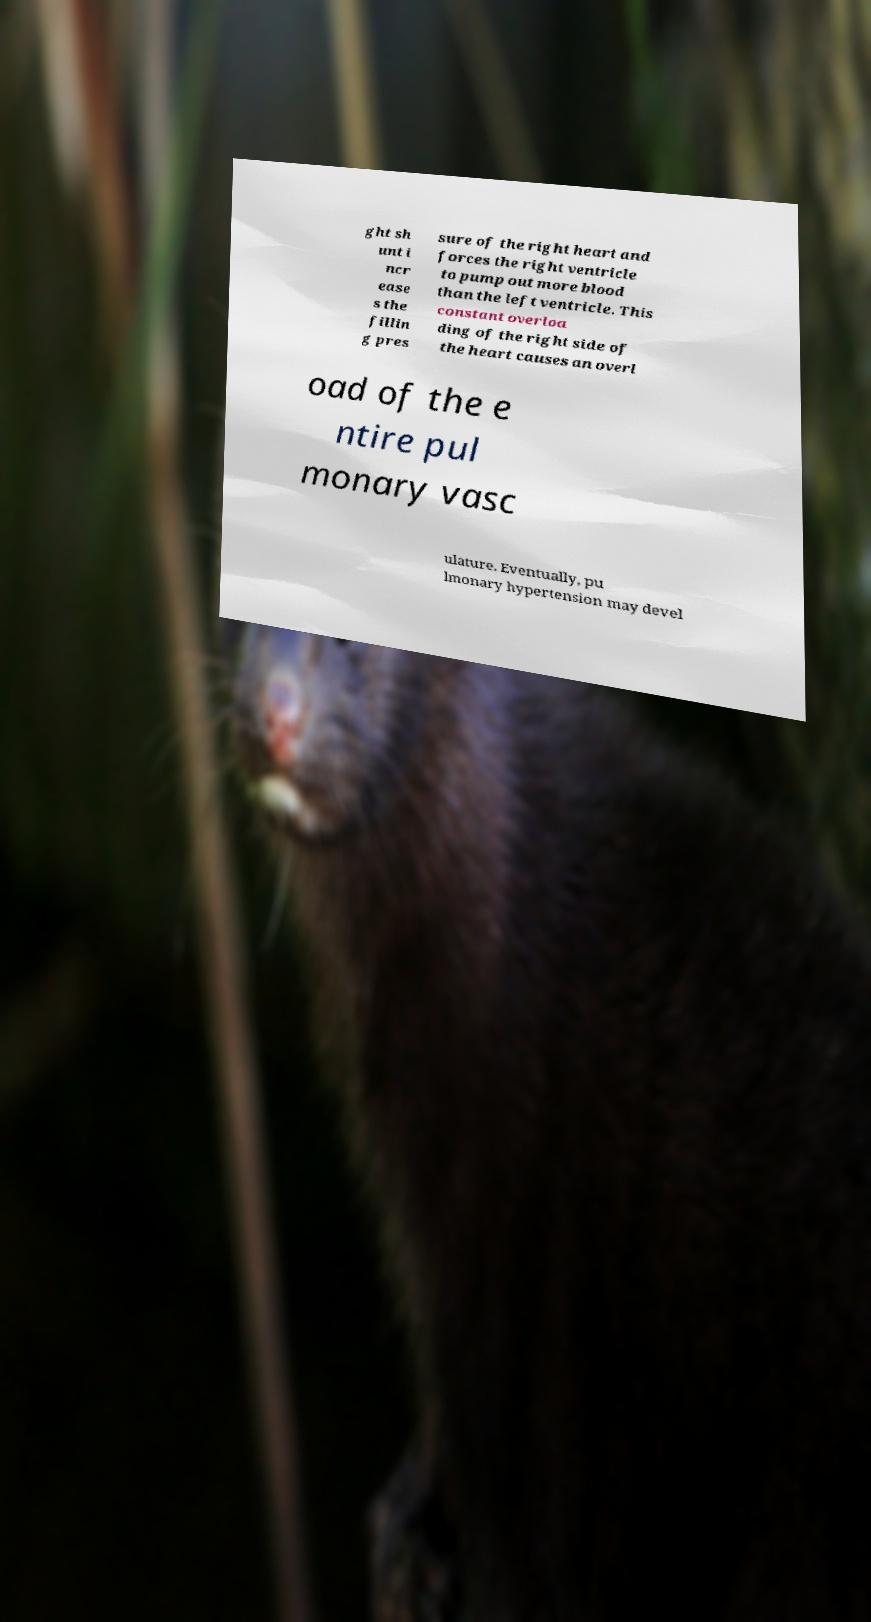Can you accurately transcribe the text from the provided image for me? ght sh unt i ncr ease s the fillin g pres sure of the right heart and forces the right ventricle to pump out more blood than the left ventricle. This constant overloa ding of the right side of the heart causes an overl oad of the e ntire pul monary vasc ulature. Eventually, pu lmonary hypertension may devel 